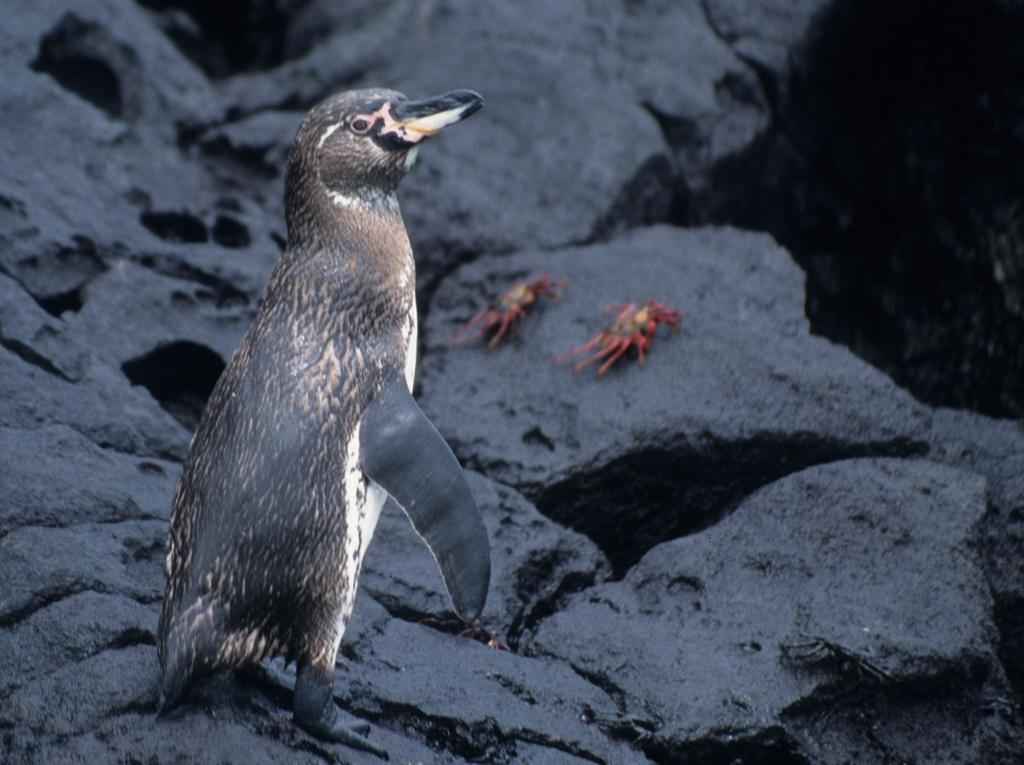What type of animal is the main subject of the image? There is a penguin in the image. Can you describe the position of the penguin? The penguin is standing in front. What other animals can be seen in the image? There are two crows in the background of the image. How would you describe the background of the image? The background appears to be slightly blurry. What type of lettuce is being used as a prop in the image? There is no lettuce present in the image. Can you read the letters on the structure in the image? There is no structure or letters present in the image. 